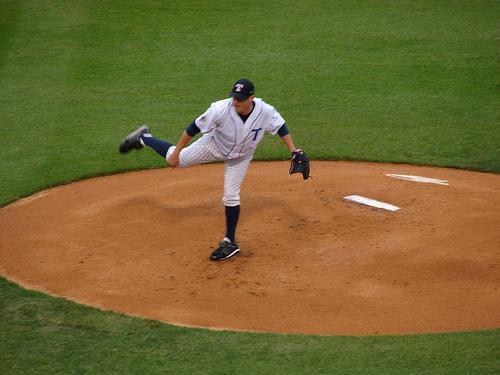How many people are pictured?
Give a very brief answer. 1. 